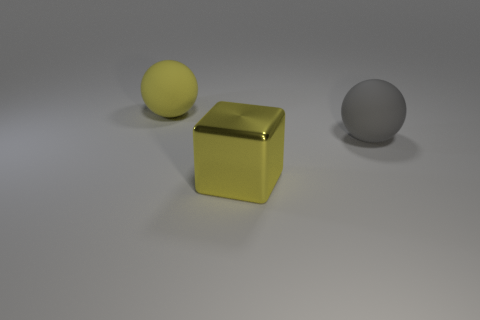Are there any other things that have the same material as the big block?
Offer a very short reply. No. There is a sphere on the left side of the big yellow shiny cube; is there a big shiny thing that is in front of it?
Provide a succinct answer. Yes. What shape is the thing that is made of the same material as the big yellow ball?
Your response must be concise. Sphere. Is there any other thing of the same color as the metal thing?
Provide a short and direct response. Yes. There is a yellow object that is on the right side of the big ball that is on the left side of the big gray rubber object; what is it made of?
Ensure brevity in your answer.  Metal. Is there a yellow shiny thing of the same shape as the large gray thing?
Make the answer very short. No. What number of other things are there of the same shape as the yellow metallic object?
Make the answer very short. 0. The big thing that is to the left of the gray rubber thing and right of the large yellow rubber thing has what shape?
Your response must be concise. Cube. There is a gray matte sphere that is to the right of the cube; how big is it?
Offer a terse response. Large. Is the yellow shiny cube the same size as the gray rubber thing?
Make the answer very short. Yes. 